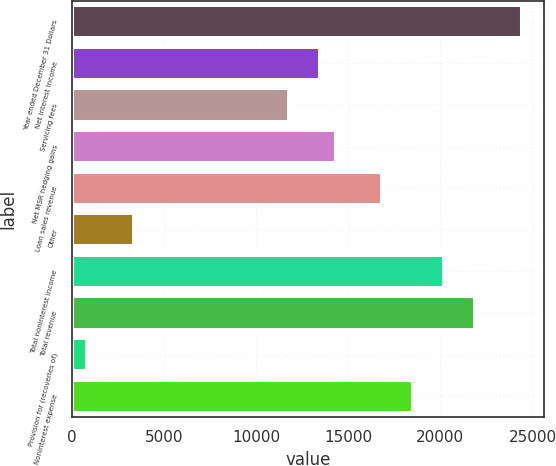Convert chart. <chart><loc_0><loc_0><loc_500><loc_500><bar_chart><fcel>Year ended December 31 Dollars<fcel>Net interest income<fcel>Servicing fees<fcel>Net MSR hedging gains<fcel>Loan sales revenue<fcel>Other<fcel>Total noninterest income<fcel>Total revenue<fcel>Provision for (recoveries of)<fcel>Noninterest expense<nl><fcel>24415.5<fcel>13471.2<fcel>11787.5<fcel>14313.1<fcel>16838.7<fcel>3368.78<fcel>20206.2<fcel>21889.9<fcel>843.17<fcel>18522.4<nl></chart> 